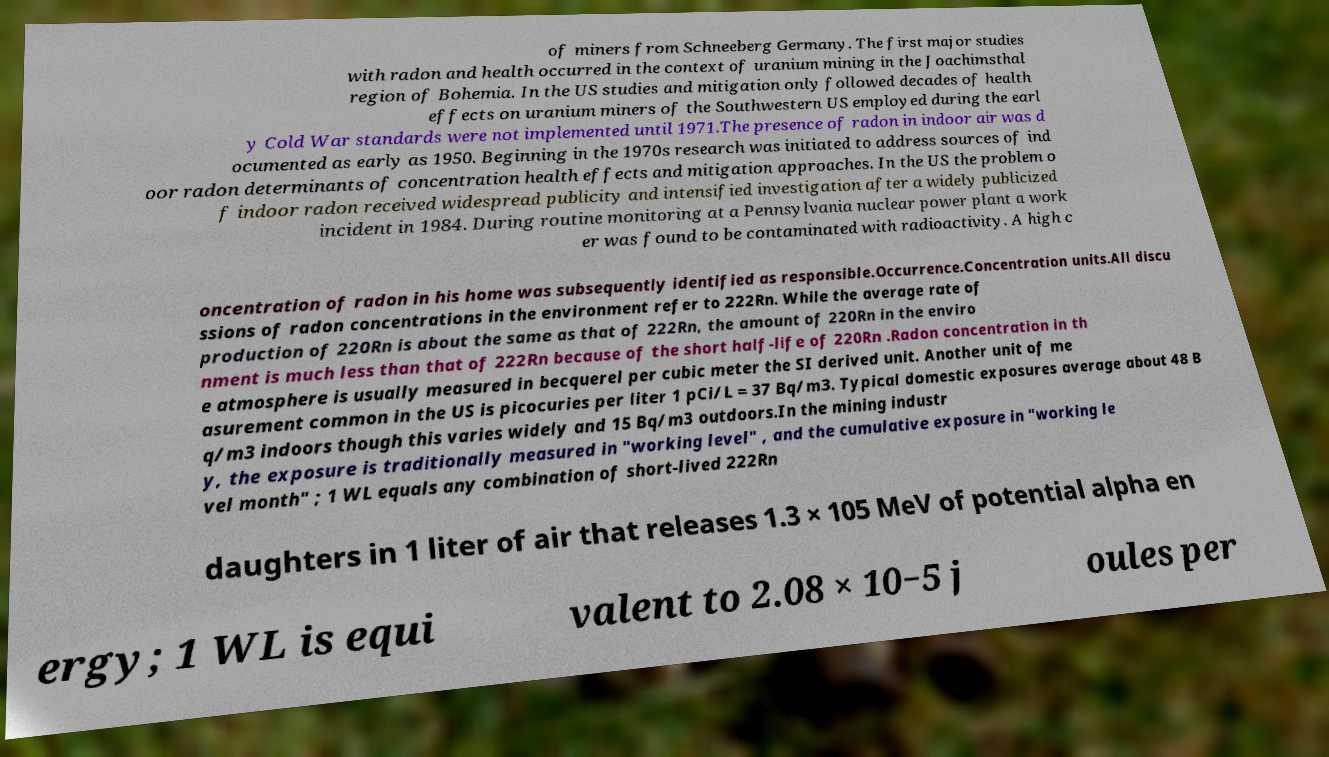Could you assist in decoding the text presented in this image and type it out clearly? of miners from Schneeberg Germany. The first major studies with radon and health occurred in the context of uranium mining in the Joachimsthal region of Bohemia. In the US studies and mitigation only followed decades of health effects on uranium miners of the Southwestern US employed during the earl y Cold War standards were not implemented until 1971.The presence of radon in indoor air was d ocumented as early as 1950. Beginning in the 1970s research was initiated to address sources of ind oor radon determinants of concentration health effects and mitigation approaches. In the US the problem o f indoor radon received widespread publicity and intensified investigation after a widely publicized incident in 1984. During routine monitoring at a Pennsylvania nuclear power plant a work er was found to be contaminated with radioactivity. A high c oncentration of radon in his home was subsequently identified as responsible.Occurrence.Concentration units.All discu ssions of radon concentrations in the environment refer to 222Rn. While the average rate of production of 220Rn is about the same as that of 222Rn, the amount of 220Rn in the enviro nment is much less than that of 222Rn because of the short half-life of 220Rn .Radon concentration in th e atmosphere is usually measured in becquerel per cubic meter the SI derived unit. Another unit of me asurement common in the US is picocuries per liter 1 pCi/L = 37 Bq/m3. Typical domestic exposures average about 48 B q/m3 indoors though this varies widely and 15 Bq/m3 outdoors.In the mining industr y, the exposure is traditionally measured in "working level" , and the cumulative exposure in "working le vel month" ; 1 WL equals any combination of short-lived 222Rn daughters in 1 liter of air that releases 1.3 × 105 MeV of potential alpha en ergy; 1 WL is equi valent to 2.08 × 10−5 j oules per 